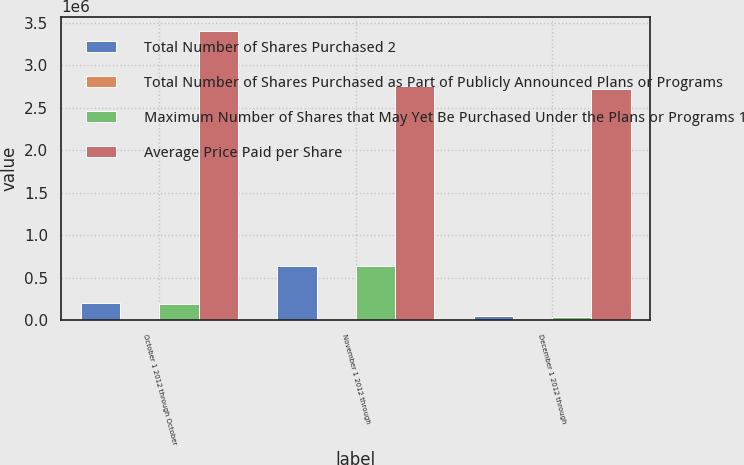Convert chart to OTSL. <chart><loc_0><loc_0><loc_500><loc_500><stacked_bar_chart><ecel><fcel>October 1 2012 through October<fcel>November 1 2012 through<fcel>December 1 2012 through<nl><fcel>Total Number of Shares Purchased 2<fcel>199312<fcel>644724<fcel>48029<nl><fcel>Total Number of Shares Purchased as Part of Publicly Announced Plans or Programs<fcel>187.87<fcel>191.16<fcel>197.54<nl><fcel>Maximum Number of Shares that May Yet Be Purchased Under the Plans or Programs 1<fcel>189000<fcel>642000<fcel>37500<nl><fcel>Average Price Paid per Share<fcel>3.4049e+06<fcel>2.7629e+06<fcel>2.7254e+06<nl></chart> 